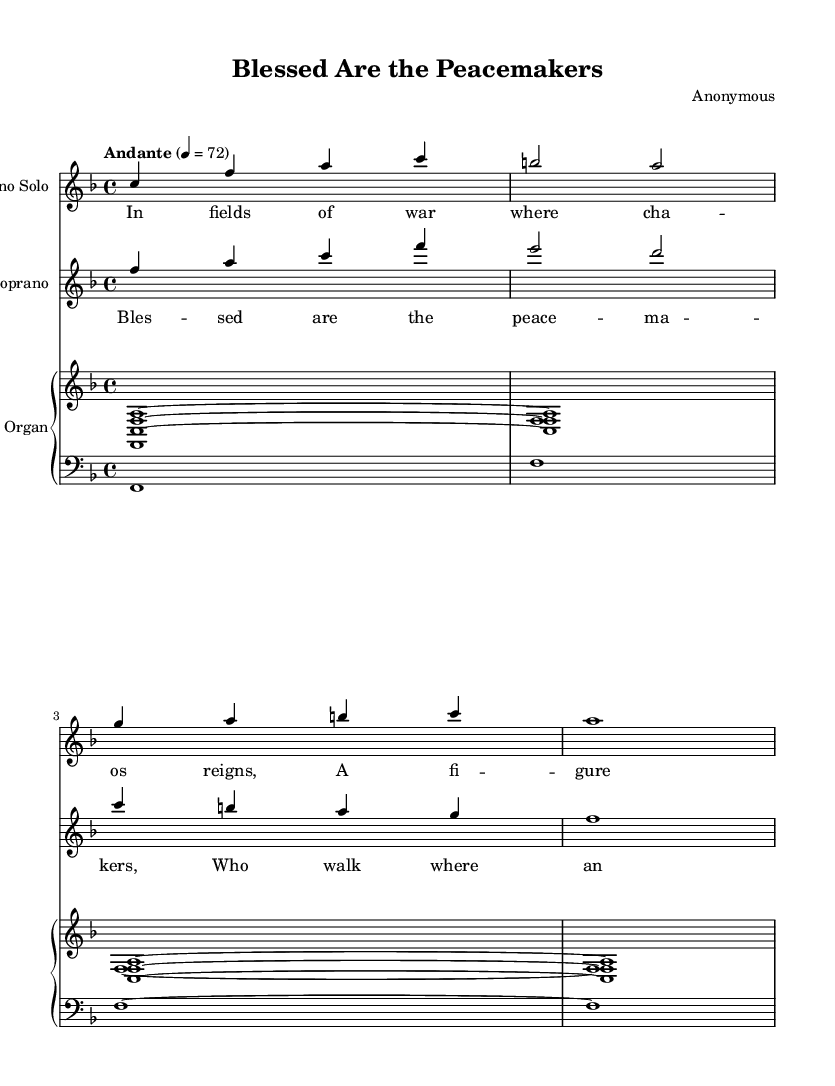What is the key signature of this music? The key signature is indicated at the beginning of the staff. It is F major, which has one flat (B flat).
Answer: F major What is the time signature of the piece? The time signature is displayed at the start of the score. It is 4/4, meaning there are four beats in a measure.
Answer: 4/4 What is the tempo marking for the piece? The tempo marking indicates how fast the piece should be played. Here, it states "Andante" with a metronome marking of 72, suggesting a moderately slow pace.
Answer: Andante, 72 How many voices are in the soprano parts? By examining the score, there are two distinct soprano parts shown: a solo soprano and a choir soprano.
Answer: Two What is the lyrical theme of the first verse? The lyrics for the first verse reference a figure standing with arms outstretched in fields of war, signifying a role of peace amid chaos.
Answer: Peace amid chaos What is the primary role of the figure mentioned in the first verse? The lyrics suggest that the figure acts as a peacekeeper in a combat zone, standing in a combat setting.
Answer: Peacekeeper How is harmony created in the organ part? The organ part consists of two voices playing chordal accompaniment, which together create harmonic support for the melody of the soprano voices.
Answer: Chordal accompaniment 